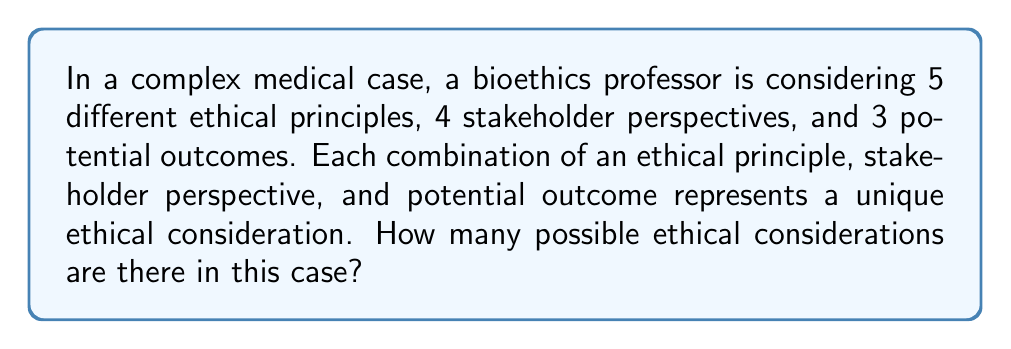Provide a solution to this math problem. Let's approach this step-by-step using the multiplication principle of counting:

1) We have three independent choices to make:
   - Choose an ethical principle (5 options)
   - Choose a stakeholder perspective (4 options)
   - Choose a potential outcome (3 options)

2) For each ethical principle, we can choose any of the 4 stakeholder perspectives, and for each of these combinations, we can choose any of the 3 potential outcomes.

3) According to the multiplication principle, when we have independent choices, we multiply the number of options for each choice:

   $$ \text{Total ethical considerations} = 5 \times 4 \times 3 $$

4) Calculating this:
   $$ 5 \times 4 \times 3 = 20 \times 3 = 60 $$

Therefore, there are 60 possible ethical considerations in this complex medical case.
Answer: 60 